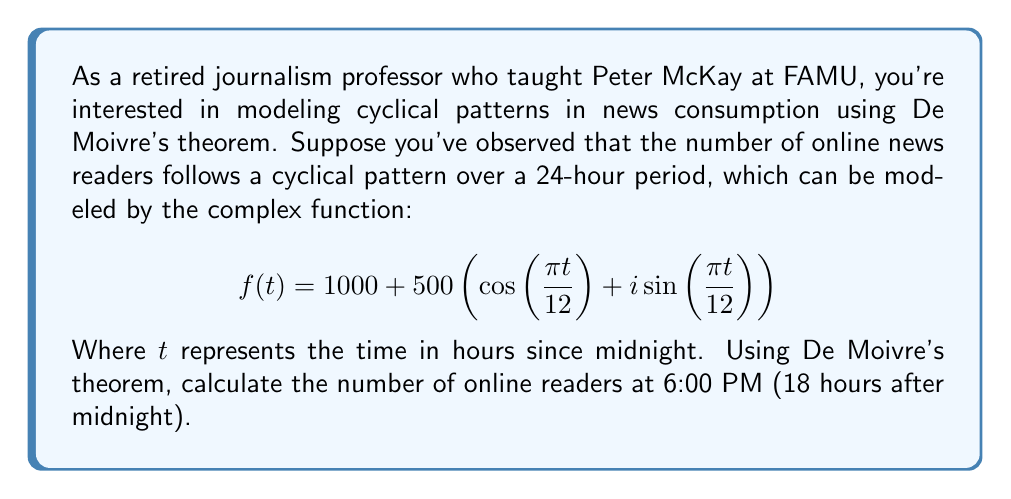Help me with this question. To solve this problem, we'll use De Moivre's theorem and follow these steps:

1) De Moivre's theorem states that for any real number $x$ and integer $n$:

   $$(\cos(x) + i\sin(x))^n = \cos(nx) + i\sin(nx)$$

2) In our case, we need to evaluate $f(18)$, so we'll substitute $t = 18$ into our function:

   $$f(18) = 1000 + 500(\cos(\frac{18\pi}{12}) + i\sin(\frac{18\pi}{12}))$$

3) Simplify the argument of the trigonometric functions:

   $$\frac{18\pi}{12} = \frac{3\pi}{2}$$

4) Now our function looks like:

   $$f(18) = 1000 + 500(\cos(\frac{3\pi}{2}) + i\sin(\frac{3\pi}{2}))$$

5) Recall the values of cosine and sine at $\frac{3\pi}{2}$:

   $$\cos(\frac{3\pi}{2}) = 0$$
   $$\sin(\frac{3\pi}{2}) = -1$$

6) Substituting these values:

   $$f(18) = 1000 + 500(0 - i)$$

7) Simplify:

   $$f(18) = 1000 - 500i$$

8) To find the number of readers, we need the magnitude of this complex number:

   $$|f(18)| = \sqrt{1000^2 + (-500)^2} = \sqrt{1,000,000 + 250,000} = \sqrt{1,250,000}$$

9) Calculate the final result:

   $$|f(18)| = 1118.03$$
Answer: The number of online readers at 6:00 PM is approximately 1118. 